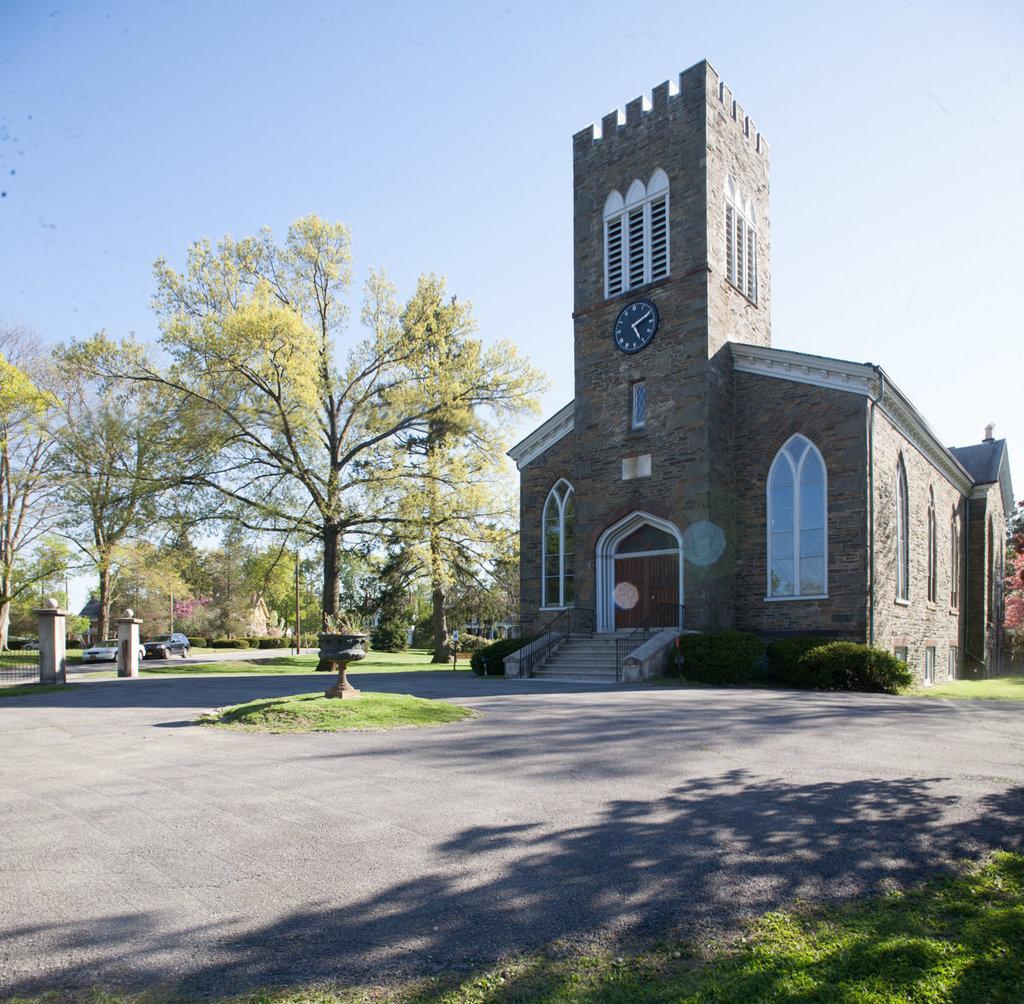How would you summarize this image in a sentence or two? In the foreground of this image, there is grass and the road. In the middle, there is a tree, a pot like an object on the grass and a building. In the background, there are trees, entrances pole and the sky at the top. 